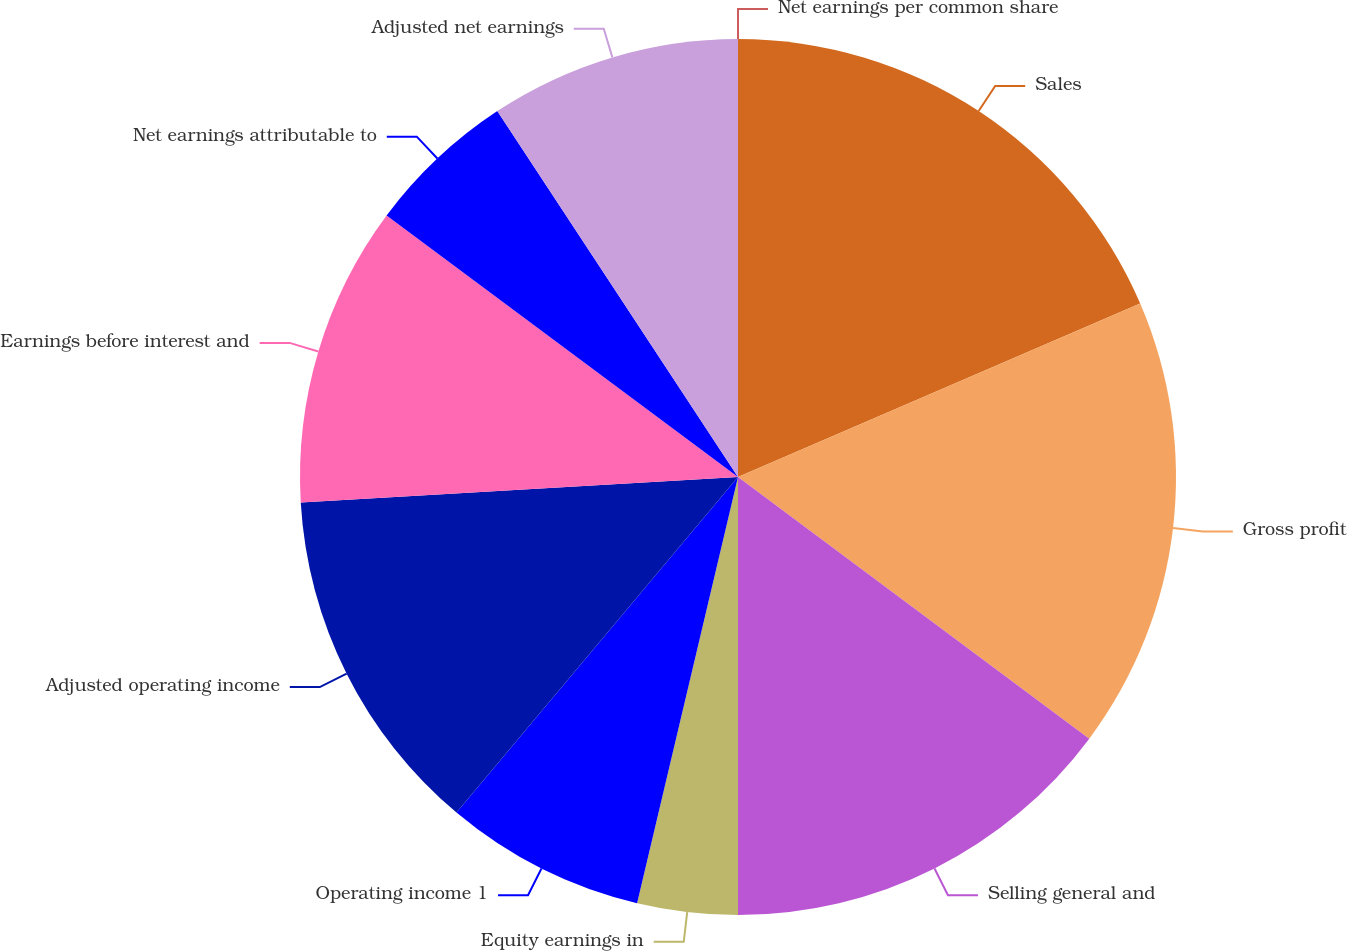Convert chart. <chart><loc_0><loc_0><loc_500><loc_500><pie_chart><fcel>Sales<fcel>Gross profit<fcel>Selling general and<fcel>Equity earnings in<fcel>Operating income 1<fcel>Adjusted operating income<fcel>Earnings before interest and<fcel>Net earnings attributable to<fcel>Adjusted net earnings<fcel>Net earnings per common share<nl><fcel>18.52%<fcel>16.67%<fcel>14.81%<fcel>3.7%<fcel>7.41%<fcel>12.96%<fcel>11.11%<fcel>5.56%<fcel>9.26%<fcel>0.0%<nl></chart> 